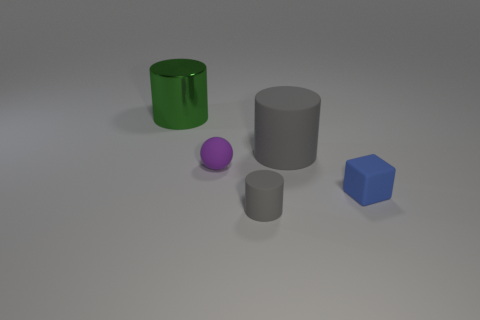What number of objects are things that are on the left side of the matte cube or matte cylinders that are in front of the small blue matte block?
Your answer should be compact. 4. There is a matte cylinder that is behind the object that is right of the big cylinder in front of the green metal thing; what is its color?
Your response must be concise. Gray. Is there a small gray matte thing of the same shape as the small blue thing?
Your response must be concise. No. What number of small blue things are there?
Provide a short and direct response. 1. There is a small blue object; what shape is it?
Your response must be concise. Cube. How many objects are the same size as the blue rubber block?
Offer a very short reply. 2. Is the tiny gray object the same shape as the big green object?
Offer a terse response. Yes. What is the color of the cylinder that is to the right of the gray rubber cylinder in front of the small blue cube?
Offer a terse response. Gray. There is a object that is both right of the small rubber cylinder and behind the blue rubber thing; what size is it?
Your answer should be compact. Large. Is there anything else of the same color as the tiny matte cube?
Make the answer very short. No. 